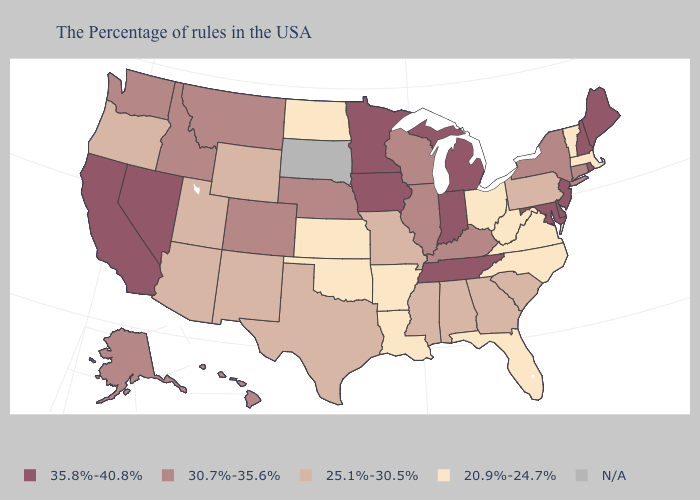What is the value of Missouri?
Be succinct. 25.1%-30.5%. Name the states that have a value in the range 20.9%-24.7%?
Be succinct. Massachusetts, Vermont, Virginia, North Carolina, West Virginia, Ohio, Florida, Louisiana, Arkansas, Kansas, Oklahoma, North Dakota. Name the states that have a value in the range N/A?
Quick response, please. South Dakota. What is the value of Oregon?
Write a very short answer. 25.1%-30.5%. What is the highest value in the USA?
Keep it brief. 35.8%-40.8%. Among the states that border West Virginia , which have the lowest value?
Write a very short answer. Virginia, Ohio. What is the value of Kentucky?
Give a very brief answer. 30.7%-35.6%. Among the states that border Kentucky , which have the lowest value?
Keep it brief. Virginia, West Virginia, Ohio. Does South Carolina have the highest value in the USA?
Answer briefly. No. Which states have the highest value in the USA?
Short answer required. Maine, Rhode Island, New Hampshire, New Jersey, Delaware, Maryland, Michigan, Indiana, Tennessee, Minnesota, Iowa, Nevada, California. How many symbols are there in the legend?
Give a very brief answer. 5. Name the states that have a value in the range 25.1%-30.5%?
Keep it brief. Pennsylvania, South Carolina, Georgia, Alabama, Mississippi, Missouri, Texas, Wyoming, New Mexico, Utah, Arizona, Oregon. Which states have the lowest value in the USA?
Quick response, please. Massachusetts, Vermont, Virginia, North Carolina, West Virginia, Ohio, Florida, Louisiana, Arkansas, Kansas, Oklahoma, North Dakota. Does New Hampshire have the highest value in the Northeast?
Be succinct. Yes. What is the value of California?
Quick response, please. 35.8%-40.8%. 